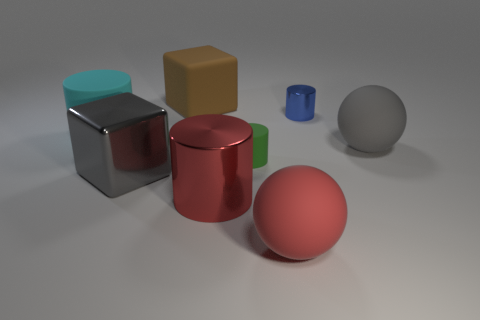Subtract 1 cylinders. How many cylinders are left? 3 Subtract all yellow balls. Subtract all green blocks. How many balls are left? 2 Add 2 gray shiny cylinders. How many objects exist? 10 Subtract all spheres. How many objects are left? 6 Add 1 small shiny things. How many small shiny things are left? 2 Add 6 large shiny cylinders. How many large shiny cylinders exist? 7 Subtract 0 green cubes. How many objects are left? 8 Subtract all large shiny blocks. Subtract all small matte cylinders. How many objects are left? 6 